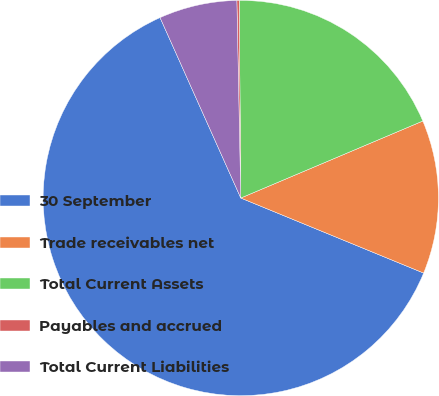Convert chart to OTSL. <chart><loc_0><loc_0><loc_500><loc_500><pie_chart><fcel>30 September<fcel>Trade receivables net<fcel>Total Current Assets<fcel>Payables and accrued<fcel>Total Current Liabilities<nl><fcel>62.11%<fcel>12.57%<fcel>18.76%<fcel>0.19%<fcel>6.38%<nl></chart> 